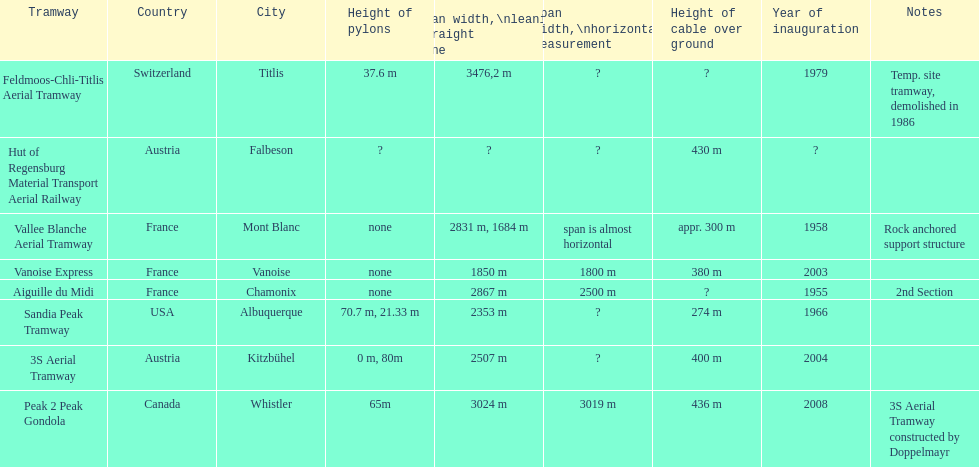At least how many aerial tramways were inaugurated after 1970? 4. 